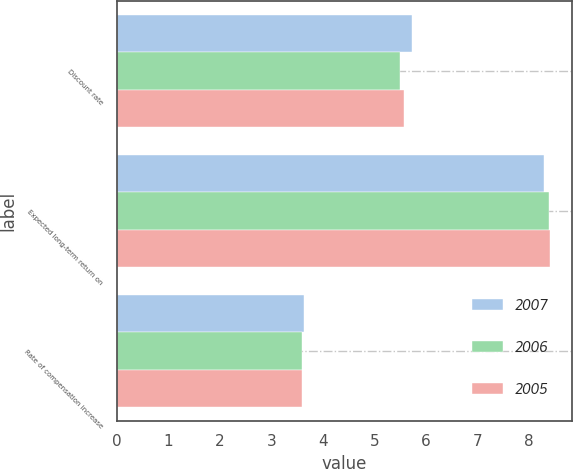<chart> <loc_0><loc_0><loc_500><loc_500><stacked_bar_chart><ecel><fcel>Discount rate<fcel>Expected long-term return on<fcel>Rate of compensation increase<nl><fcel>2007<fcel>5.74<fcel>8.3<fcel>3.63<nl><fcel>2006<fcel>5.49<fcel>8.39<fcel>3.6<nl><fcel>2005<fcel>5.57<fcel>8.41<fcel>3.59<nl></chart> 